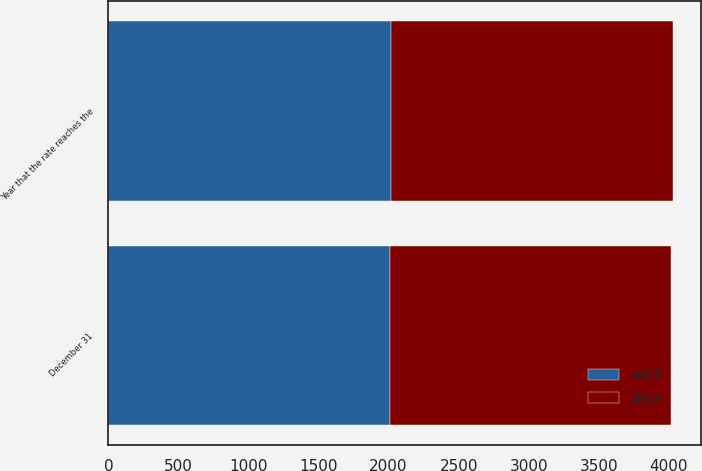Convert chart to OTSL. <chart><loc_0><loc_0><loc_500><loc_500><stacked_bar_chart><ecel><fcel>December 31<fcel>Year that the rate reaches the<nl><fcel>2012<fcel>2010<fcel>2018<nl><fcel>2018<fcel>2009<fcel>2012<nl></chart> 